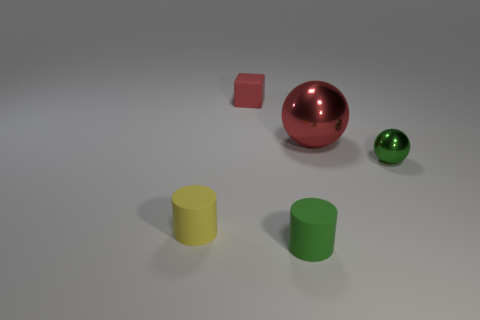Is there anything else that has the same size as the red metal sphere?
Your response must be concise. No. Is there anything else that is made of the same material as the small red cube?
Your response must be concise. Yes. The small object right of the large metal thing is what color?
Provide a short and direct response. Green. There is a tiny thing that is on the left side of the small ball and behind the yellow rubber object; what material is it?
Provide a succinct answer. Rubber. There is a tiny cylinder to the left of the small red thing; how many tiny shiny objects are in front of it?
Your answer should be very brief. 0. What shape is the tiny yellow rubber object?
Offer a terse response. Cylinder. There is a tiny green thing that is the same material as the big thing; what is its shape?
Your response must be concise. Sphere. There is a red thing that is on the right side of the small block; is its shape the same as the tiny metallic object?
Ensure brevity in your answer.  Yes. There is a rubber thing behind the large red object; what is its shape?
Keep it short and to the point. Cube. There is a big thing that is the same color as the matte block; what is its shape?
Make the answer very short. Sphere. 